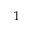<formula> <loc_0><loc_0><loc_500><loc_500>^ { 1 }</formula> 